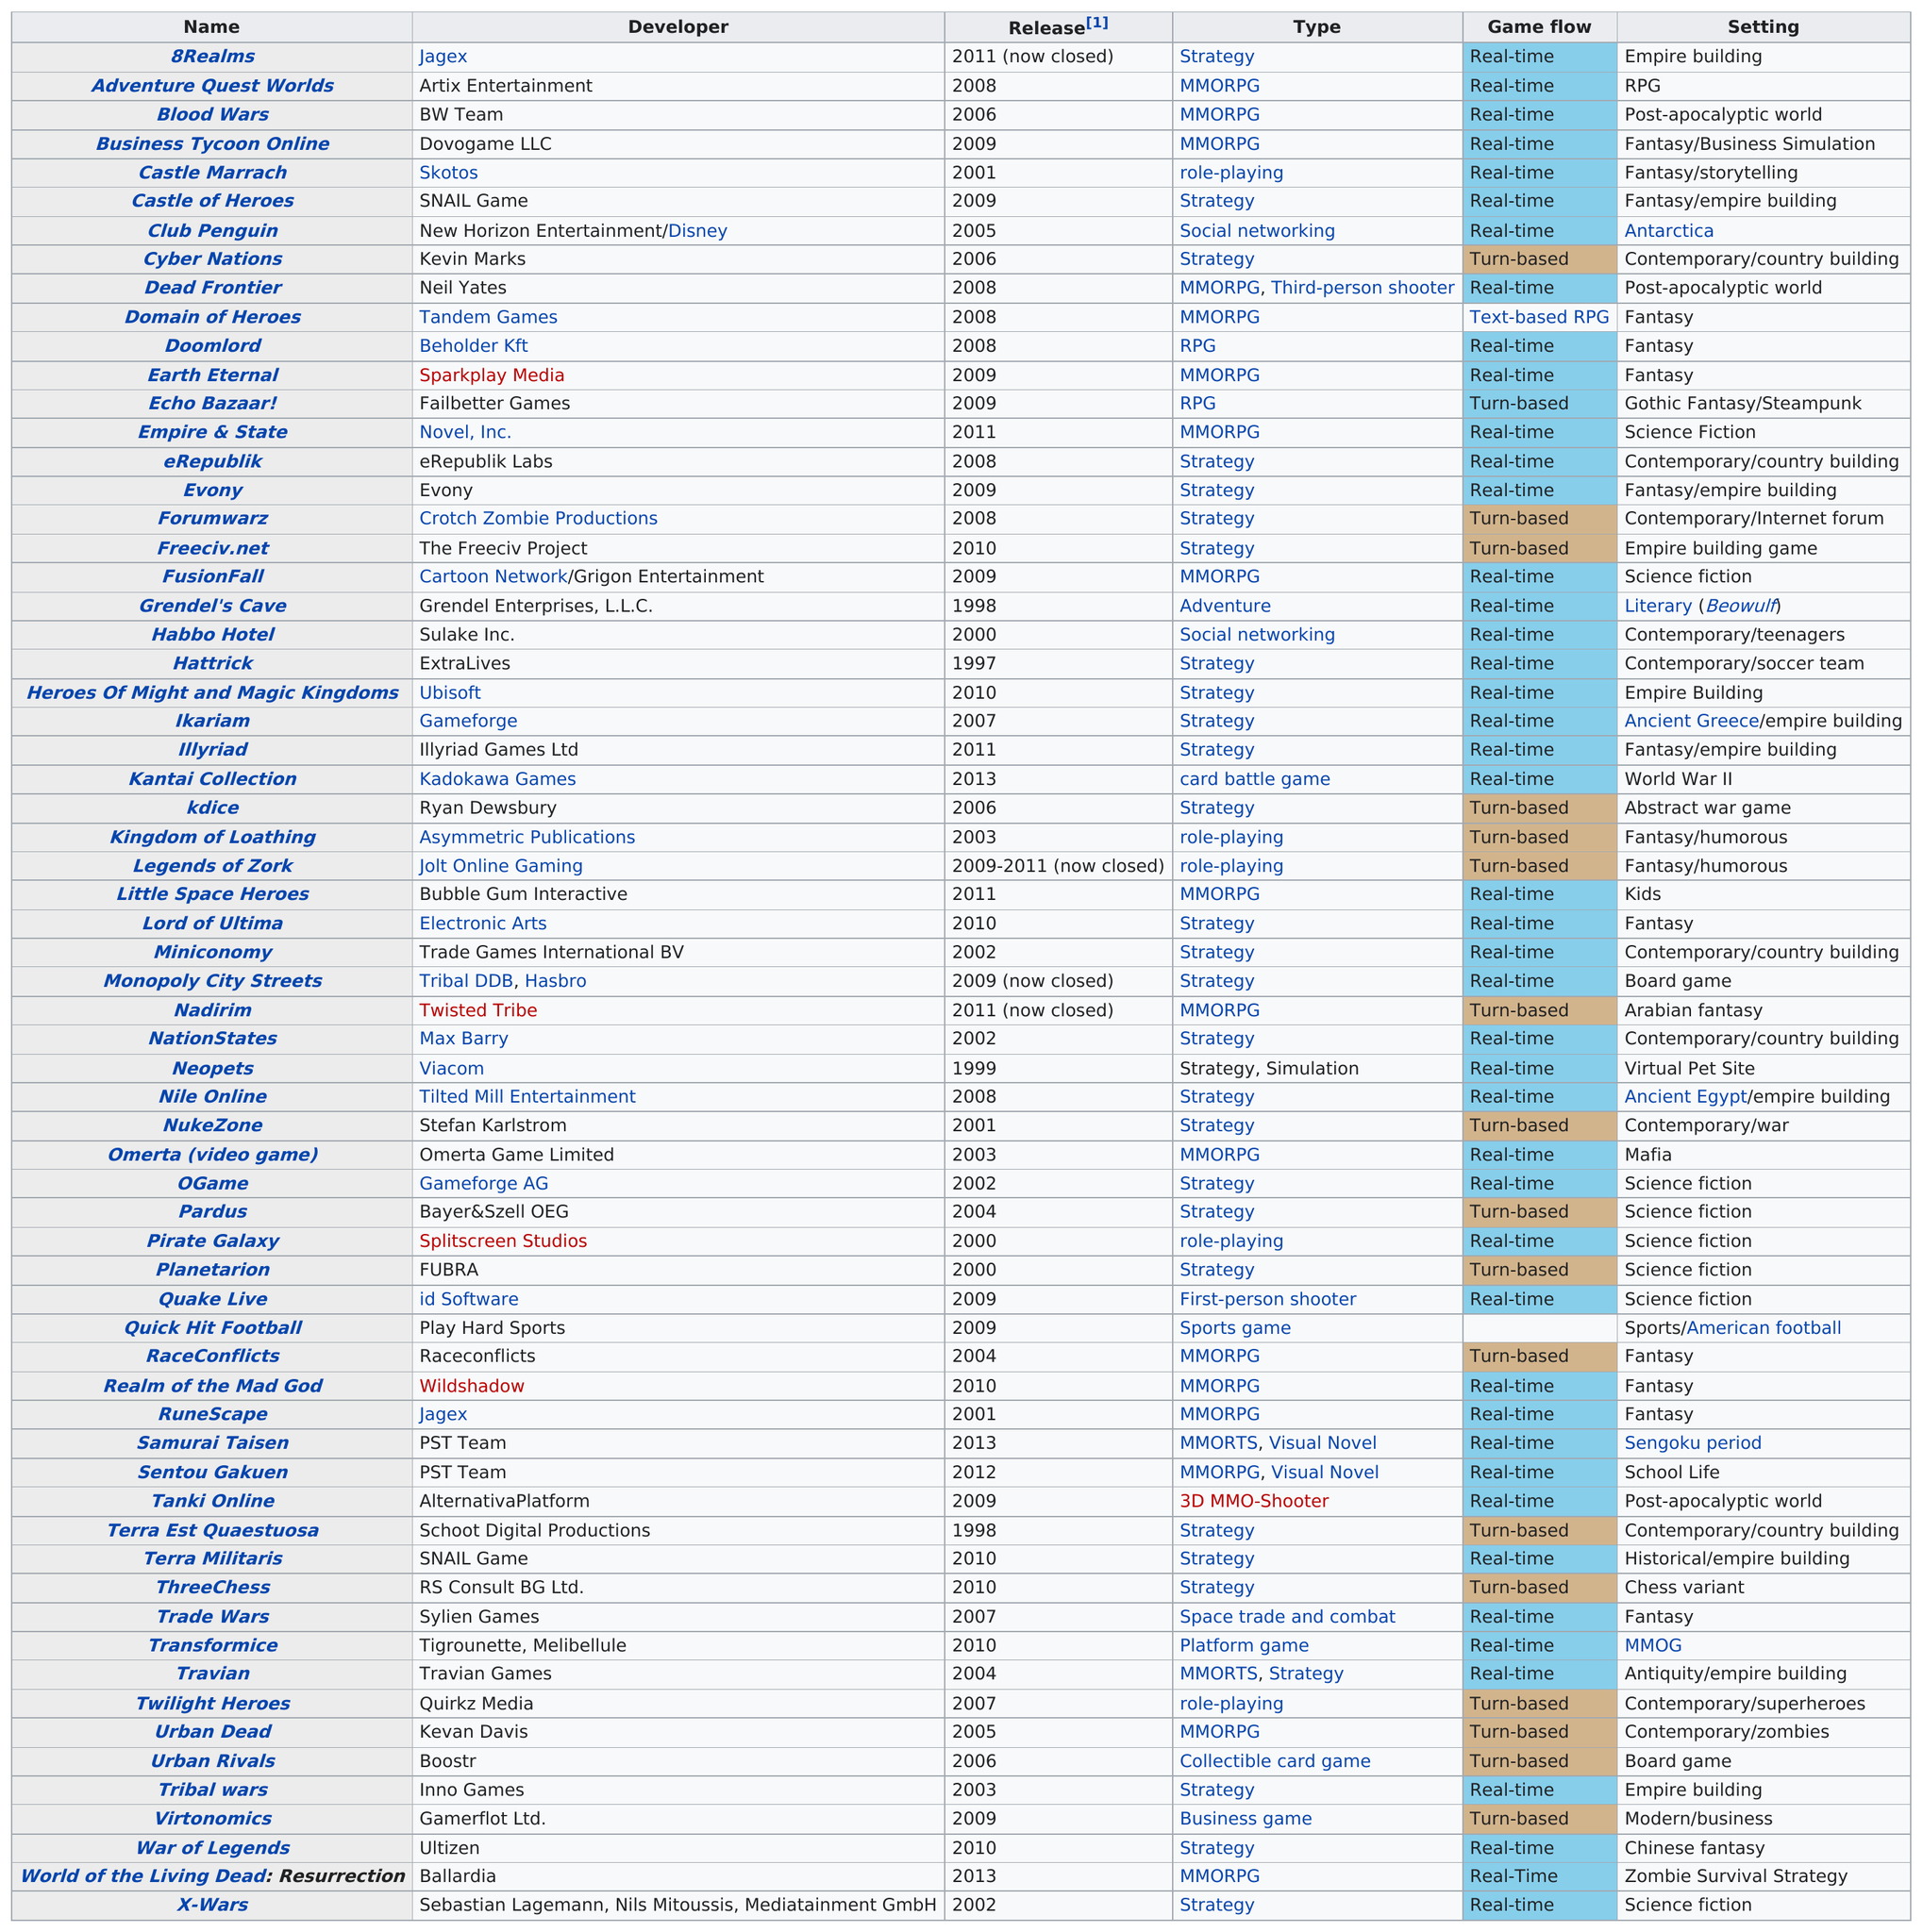Indicate a few pertinent items in this graphic. Before 2008, 28 games were released. It is the sole game released by Fubra, named Planetarion. Jagex has released multiple games, with the exact number unknown. The developer of Castle of Heroes is SNAIL Game. In 2003, there were approximately 3 multiplayer browser games released. 